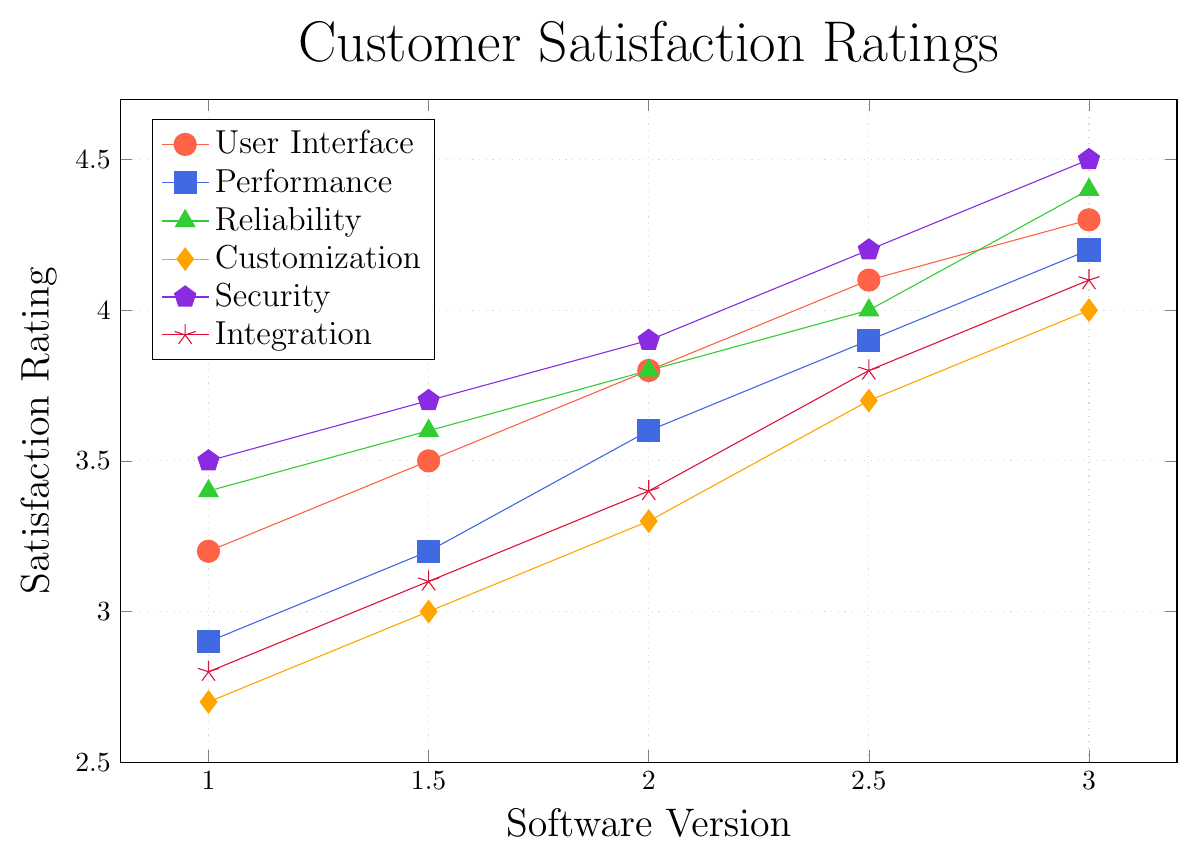What's the satisfaction rating for User Interface in version 3.0? In version 3.0, find the User Interface feature, which is marked with red dots. The satisfaction rating is next to it.
Answer: 4.3 Which feature has the highest satisfaction rating in version 3.0? For version 3.0, compare the ratings for all features. The feature with the purple pentagon shape has the highest rating.
Answer: Security How much did the satisfaction rating for Performance change from version 1.0 to 3.0? For the Performance feature, find the ratings in versions 1.0 (2.9) and 3.0 (4.2). Subtract the earlier rating from the later one.
Answer: 1.3 Which feature shows the most improvement in satisfaction rating from version 1.0 to 3.0? For each feature, calculate the difference between the ratings in version 3.0 and version 1.0. Compare these differences to find the feature with the largest value.
Answer: Security What's the average satisfaction rating for Customization across all versions? Sum the ratings for Customization (2.7, 3.0, 3.3, 3.7, 4.0) and divide by the number of versions. (2.7 + 3.0 + 3.3 + 3.7 + 4.0) / 5
Answer: 3.34 Which feature has the smallest change in satisfaction rating from version 1.0 to 3.0? For each feature, calculate the difference between version 3.0 and version 1.0. Compare these differences to identify the smallest one.
Answer: Reliability What is the combined satisfaction rating of User Interface and Integration in version 2.0? Find the ratings for User Interface (3.8) and Integration (3.4) in version 2.0. Add these ratings together.
Answer: 7.2 In which version did Reliability first reach a satisfaction rating of 4.0? Look at the ratings for Reliability over different versions and find the version where it first reaches 4.0.
Answer: 2.5 